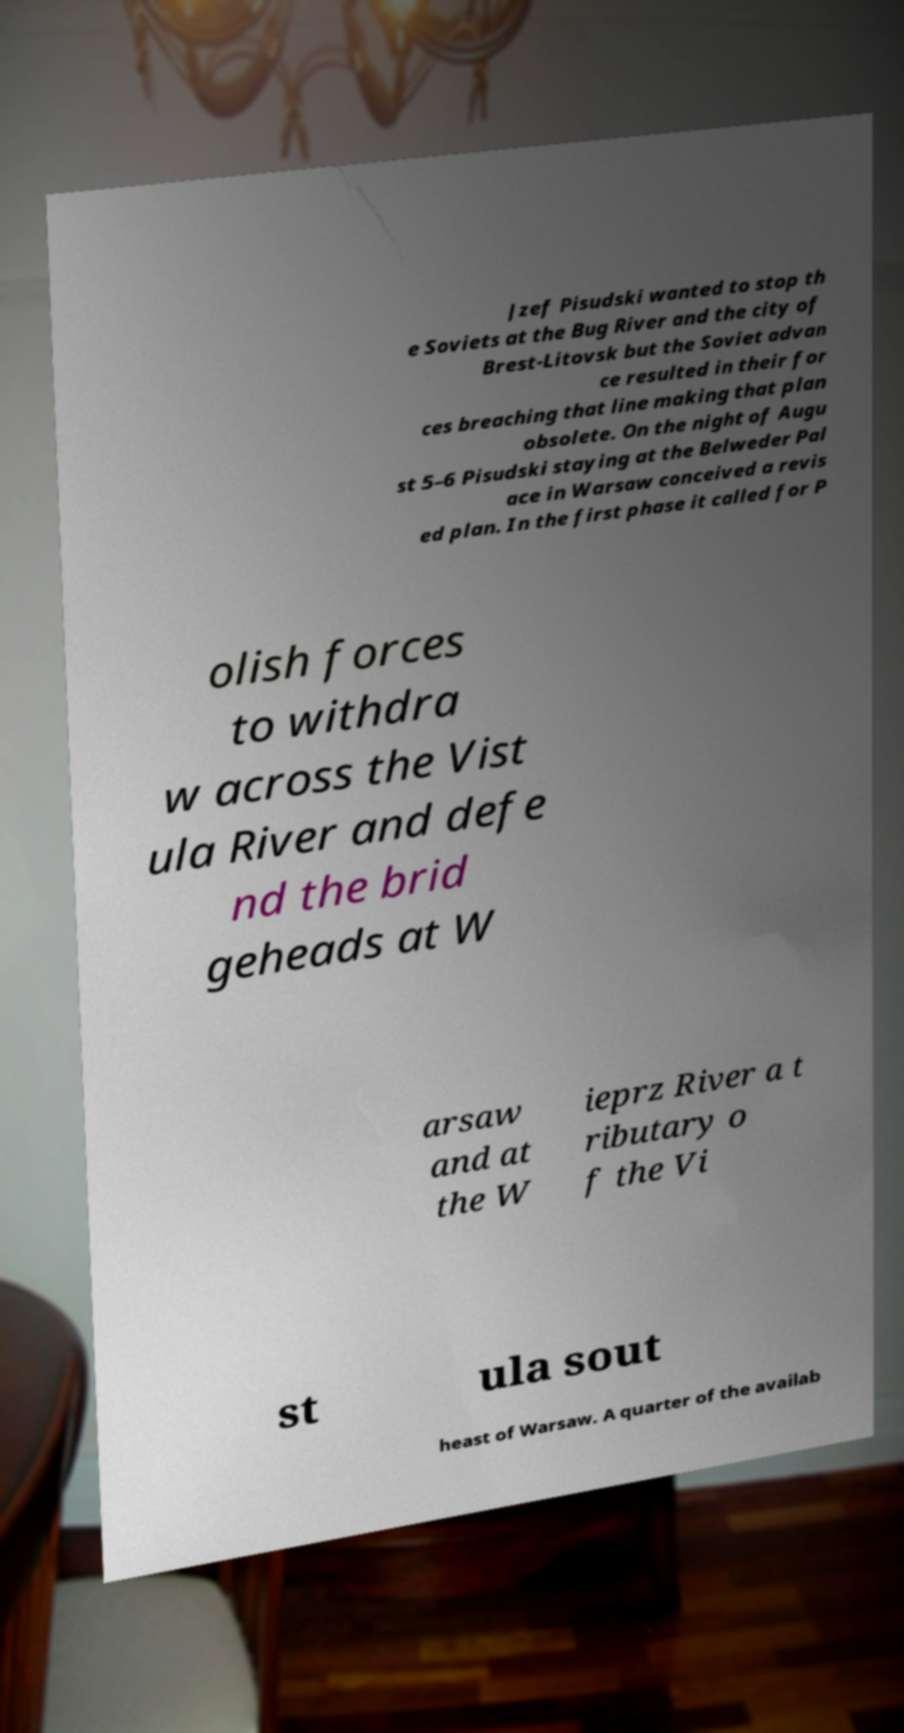Can you accurately transcribe the text from the provided image for me? Jzef Pisudski wanted to stop th e Soviets at the Bug River and the city of Brest-Litovsk but the Soviet advan ce resulted in their for ces breaching that line making that plan obsolete. On the night of Augu st 5–6 Pisudski staying at the Belweder Pal ace in Warsaw conceived a revis ed plan. In the first phase it called for P olish forces to withdra w across the Vist ula River and defe nd the brid geheads at W arsaw and at the W ieprz River a t ributary o f the Vi st ula sout heast of Warsaw. A quarter of the availab 